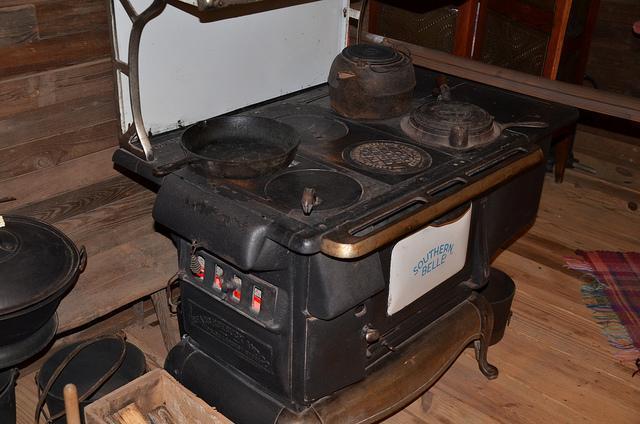How many burners does the stove have?
Give a very brief answer. 6. How many orange lights are on the right side of the truck?
Give a very brief answer. 0. 